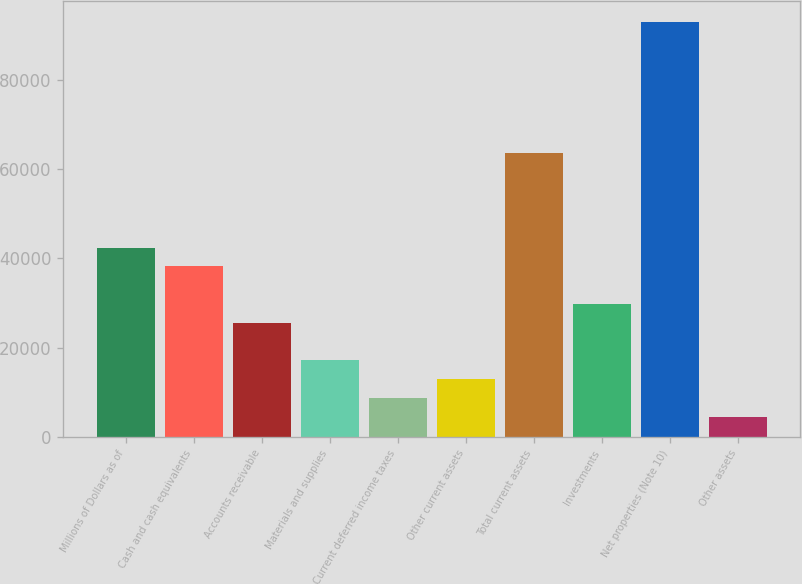Convert chart. <chart><loc_0><loc_0><loc_500><loc_500><bar_chart><fcel>Millions of Dollars as of<fcel>Cash and cash equivalents<fcel>Accounts receivable<fcel>Materials and supplies<fcel>Current deferred income taxes<fcel>Other current assets<fcel>Total current assets<fcel>Investments<fcel>Net properties (Note 10)<fcel>Other assets<nl><fcel>42410<fcel>38190.2<fcel>25530.8<fcel>17091.2<fcel>8651.6<fcel>12871.4<fcel>63509<fcel>29750.6<fcel>93047.6<fcel>4431.8<nl></chart> 